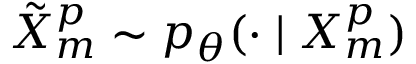<formula> <loc_0><loc_0><loc_500><loc_500>\tilde { X } _ { m } ^ { p } \sim p _ { \theta } ( \cdot | X _ { m } ^ { p } )</formula> 